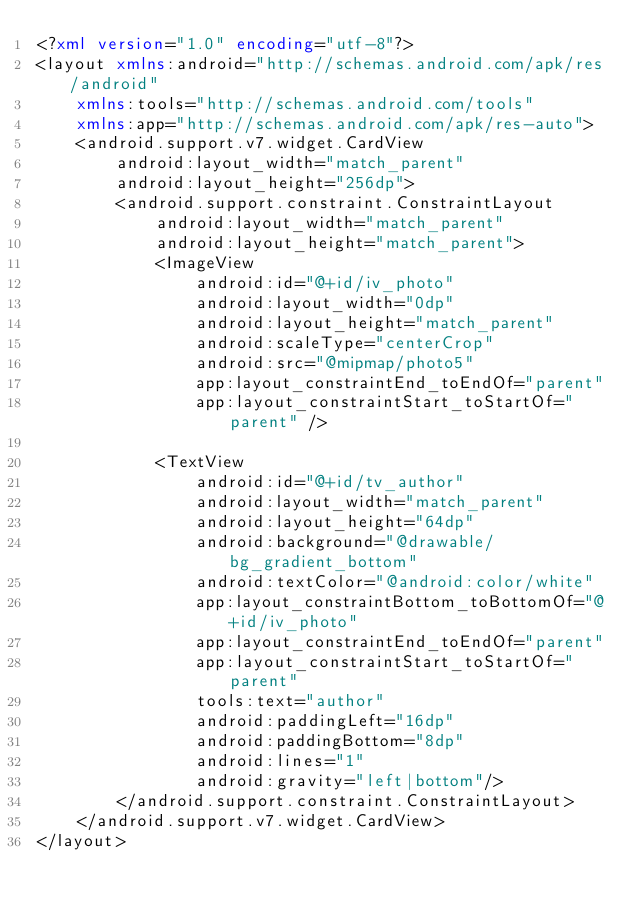<code> <loc_0><loc_0><loc_500><loc_500><_XML_><?xml version="1.0" encoding="utf-8"?>
<layout xmlns:android="http://schemas.android.com/apk/res/android"
    xmlns:tools="http://schemas.android.com/tools"
    xmlns:app="http://schemas.android.com/apk/res-auto">
    <android.support.v7.widget.CardView
        android:layout_width="match_parent"
        android:layout_height="256dp">
        <android.support.constraint.ConstraintLayout
            android:layout_width="match_parent"
            android:layout_height="match_parent">
            <ImageView
                android:id="@+id/iv_photo"
                android:layout_width="0dp"
                android:layout_height="match_parent"
                android:scaleType="centerCrop"
                android:src="@mipmap/photo5"
                app:layout_constraintEnd_toEndOf="parent"
                app:layout_constraintStart_toStartOf="parent" />

            <TextView
                android:id="@+id/tv_author"
                android:layout_width="match_parent"
                android:layout_height="64dp"
                android:background="@drawable/bg_gradient_bottom"
                android:textColor="@android:color/white"
                app:layout_constraintBottom_toBottomOf="@+id/iv_photo"
                app:layout_constraintEnd_toEndOf="parent"
                app:layout_constraintStart_toStartOf="parent"
                tools:text="author"
                android:paddingLeft="16dp"
                android:paddingBottom="8dp"
                android:lines="1"
                android:gravity="left|bottom"/>
        </android.support.constraint.ConstraintLayout>
    </android.support.v7.widget.CardView>
</layout>
</code> 